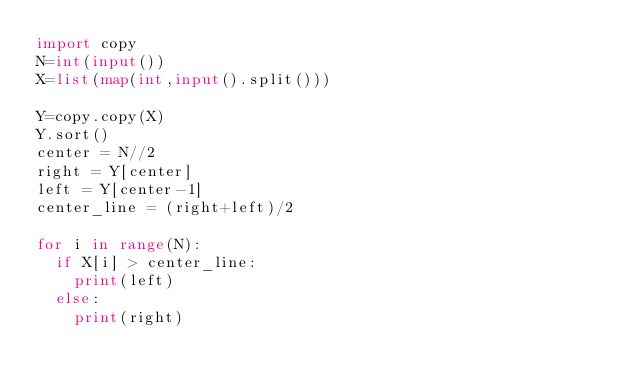Convert code to text. <code><loc_0><loc_0><loc_500><loc_500><_Python_>import copy
N=int(input())
X=list(map(int,input().split()))

Y=copy.copy(X)
Y.sort()
center = N//2
right = Y[center]
left = Y[center-1]
center_line = (right+left)/2

for i in range(N):
  if X[i] > center_line:
    print(left)
  else:
    print(right)</code> 